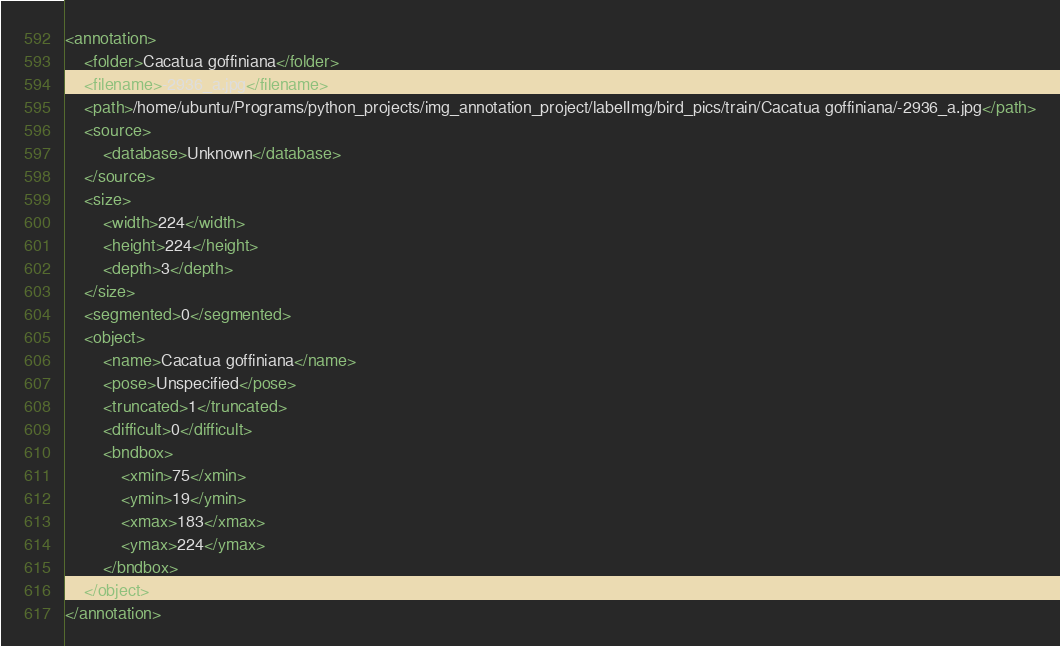<code> <loc_0><loc_0><loc_500><loc_500><_XML_><annotation>
	<folder>Cacatua goffiniana</folder>
	<filename>-2936_a.jpg</filename>
	<path>/home/ubuntu/Programs/python_projects/img_annotation_project/labelImg/bird_pics/train/Cacatua goffiniana/-2936_a.jpg</path>
	<source>
		<database>Unknown</database>
	</source>
	<size>
		<width>224</width>
		<height>224</height>
		<depth>3</depth>
	</size>
	<segmented>0</segmented>
	<object>
		<name>Cacatua goffiniana</name>
		<pose>Unspecified</pose>
		<truncated>1</truncated>
		<difficult>0</difficult>
		<bndbox>
			<xmin>75</xmin>
			<ymin>19</ymin>
			<xmax>183</xmax>
			<ymax>224</ymax>
		</bndbox>
	</object>
</annotation>
</code> 